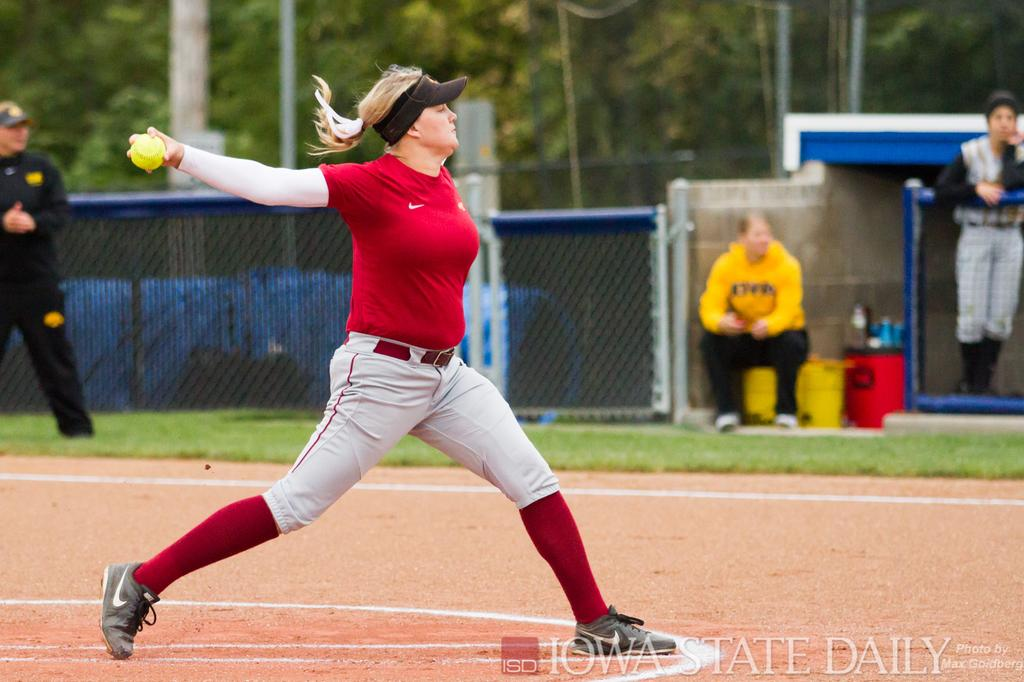<image>
Relay a brief, clear account of the picture shown. softball pitcher in red getting ready to throw photo by iowa state daily 